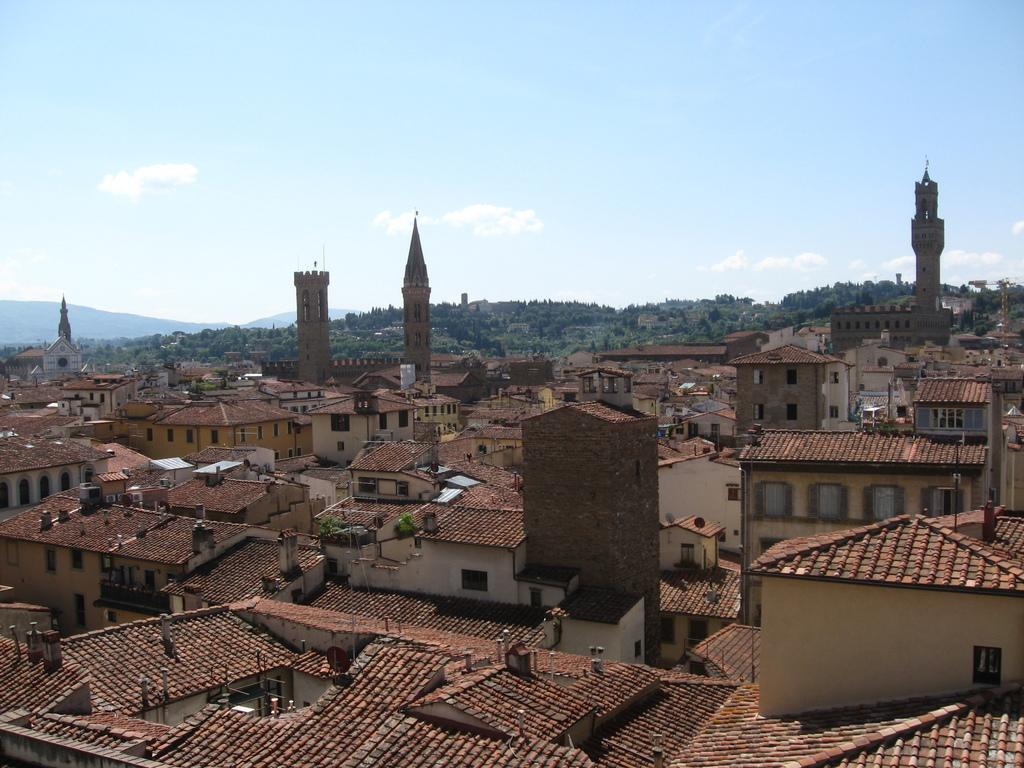What type of structures can be seen in the image? There are buildings in the image. What can be seen in the background of the image? There are trees and clouds in the background of the image. What part of the natural environment is visible in the image? The sky is visible in the background of the image. How many passengers are sitting on the bee in the image? There are no bees or passengers present in the image. 